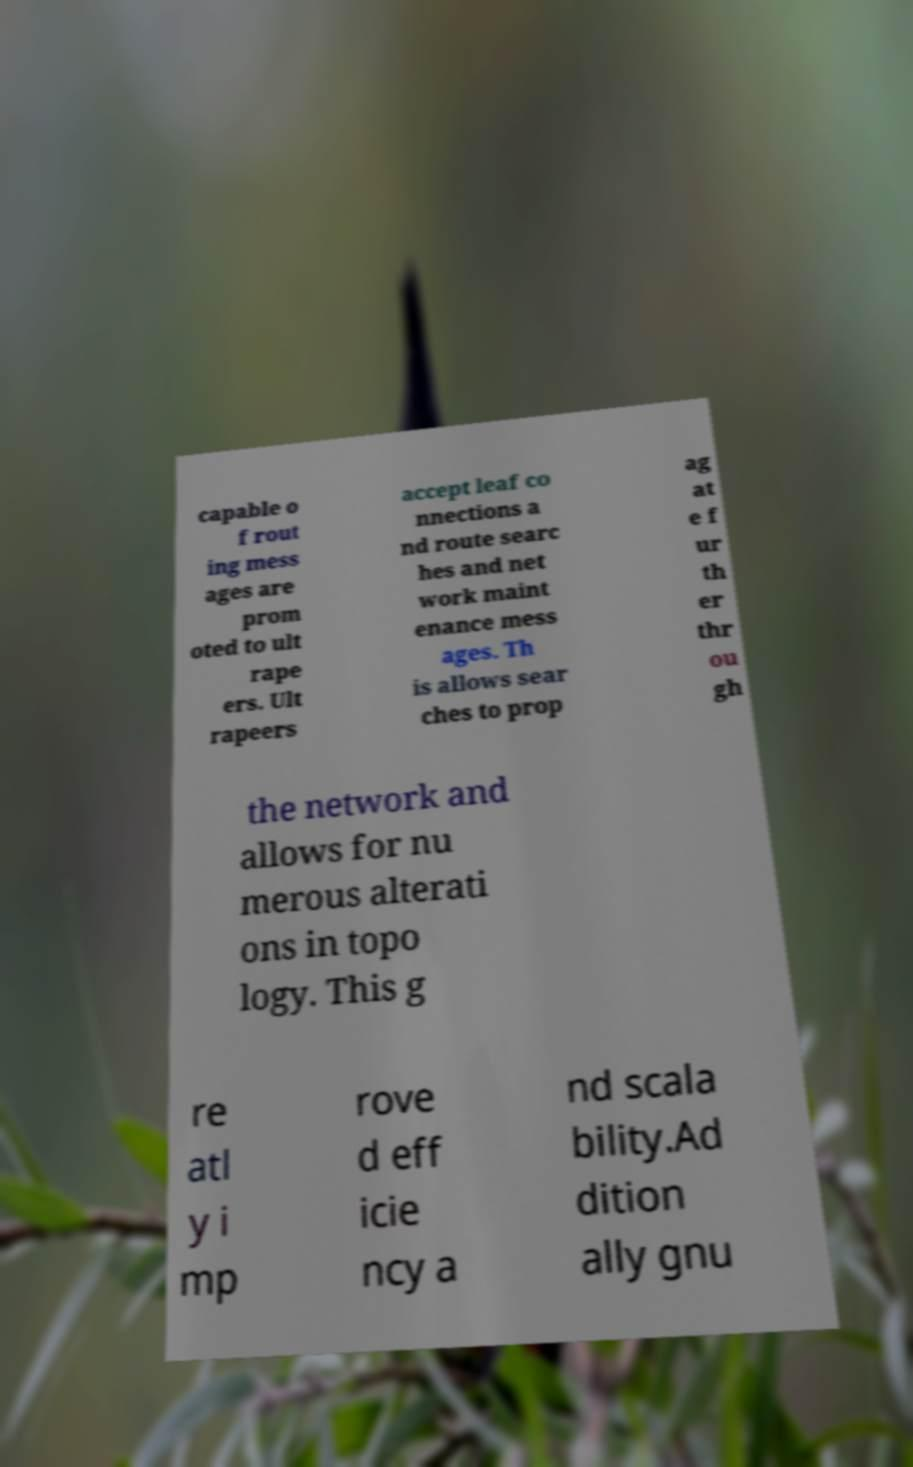Could you assist in decoding the text presented in this image and type it out clearly? capable o f rout ing mess ages are prom oted to ult rape ers. Ult rapeers accept leaf co nnections a nd route searc hes and net work maint enance mess ages. Th is allows sear ches to prop ag at e f ur th er thr ou gh the network and allows for nu merous alterati ons in topo logy. This g re atl y i mp rove d eff icie ncy a nd scala bility.Ad dition ally gnu 